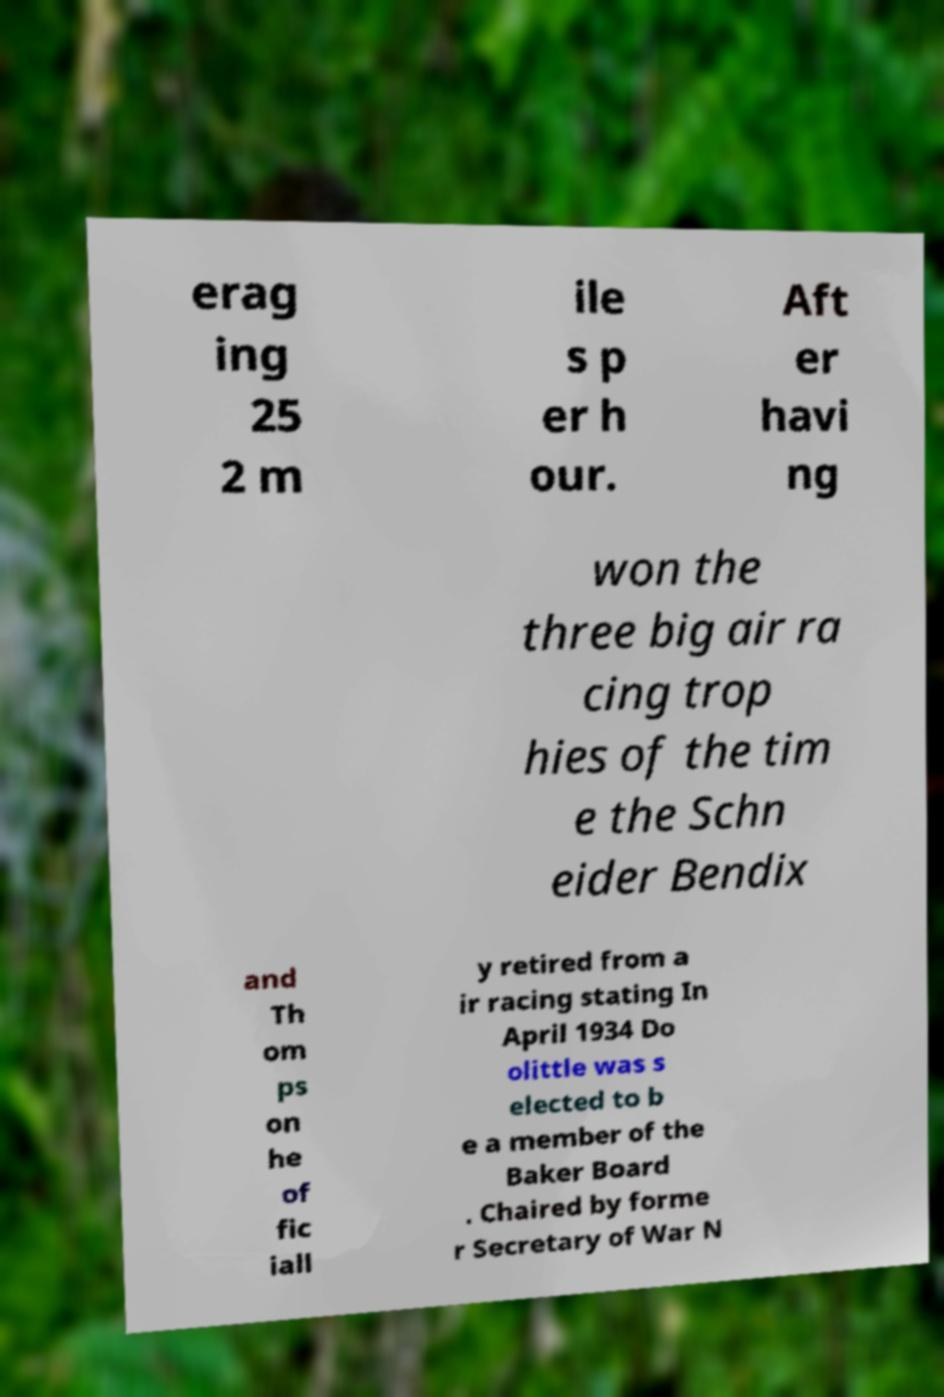Can you read and provide the text displayed in the image?This photo seems to have some interesting text. Can you extract and type it out for me? erag ing 25 2 m ile s p er h our. Aft er havi ng won the three big air ra cing trop hies of the tim e the Schn eider Bendix and Th om ps on he of fic iall y retired from a ir racing stating In April 1934 Do olittle was s elected to b e a member of the Baker Board . Chaired by forme r Secretary of War N 